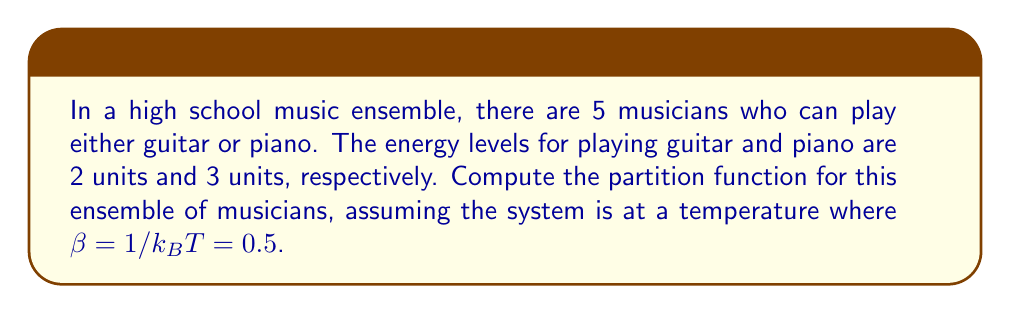Could you help me with this problem? Let's approach this step-by-step:

1) The partition function Z is given by:

   $$Z = \sum_i g_i e^{-\beta E_i}$$

   where $g_i$ is the degeneracy (number of states) with energy $E_i$.

2) In this case, we have two energy levels:
   - Guitar: $E_1 = 2$ units
   - Piano: $E_2 = 3$ units

3) For each musician, there are two possible states (guitar or piano). With 5 musicians, the total number of configurations is $2^5 = 32$.

4) To calculate the degeneracies:
   - $g_1$ (all possible configurations with $k$ guitars and $(5-k)$ pianos):
     $$g_1 = \sum_{k=0}^5 \binom{5}{k} = 32$$

5) Now, let's calculate the partition function:

   $$Z = g_1 (e^{-\beta E_1} + e^{-\beta E_2})$$

6) Substituting the values:

   $$Z = 32 (e^{-0.5 \cdot 2} + e^{-0.5 \cdot 3})$$

7) Simplifying:

   $$Z = 32 (e^{-1} + e^{-1.5})$$
   $$Z = 32 (0.3679 + 0.2231)$$
   $$Z = 32 \cdot 0.5910$$
   $$Z = 18.9120$$
Answer: $Z = 18.9120$ 